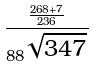<formula> <loc_0><loc_0><loc_500><loc_500>\frac { \frac { 2 6 8 + 7 } { 2 3 6 } } { 8 8 ^ { \sqrt { 3 4 7 } } }</formula> 